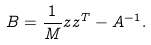Convert formula to latex. <formula><loc_0><loc_0><loc_500><loc_500>B = \frac { 1 } { M } z z ^ { T } - A ^ { - 1 } .</formula> 